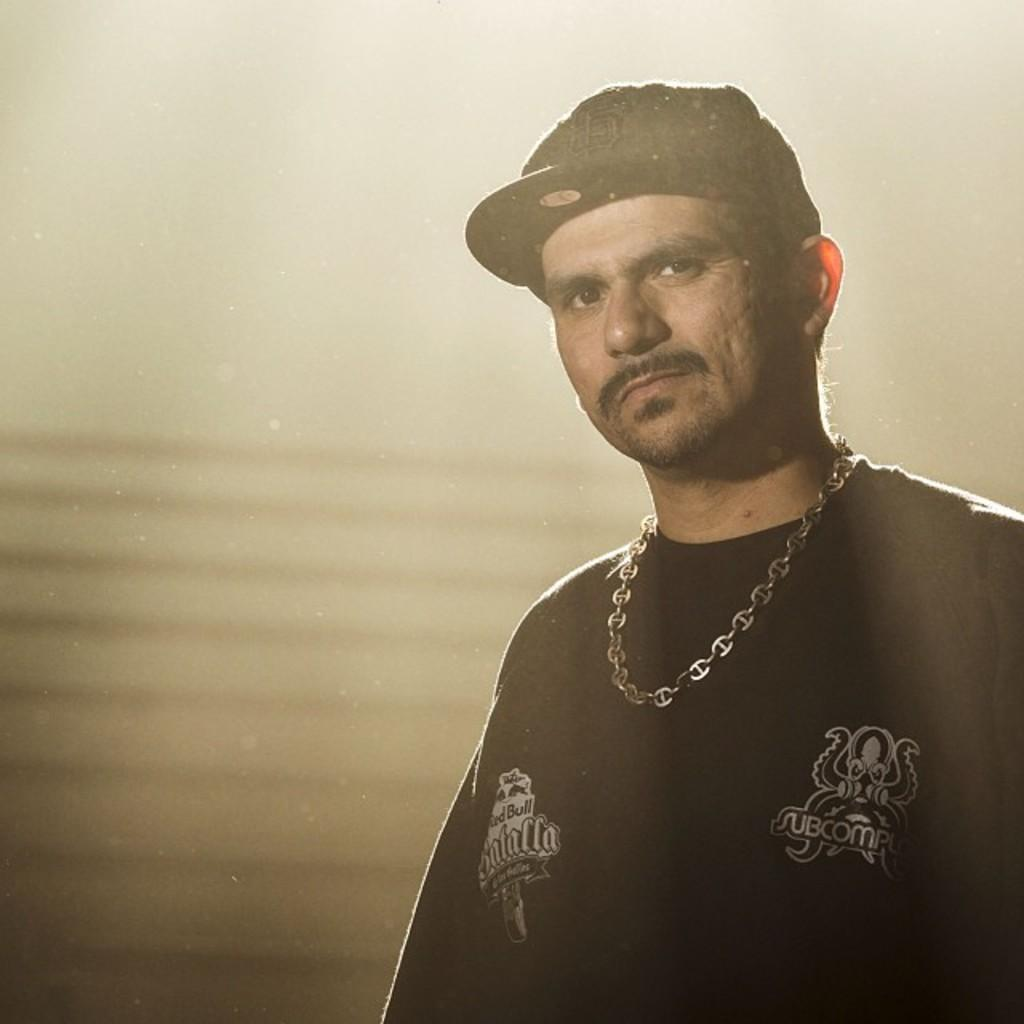Who is in the image? There is a person in the image. What is the person wearing on their upper body? The person is wearing a black t-shirt. What type of accessory is the person wearing? The person is wearing a chain. What type of headwear is the person wearing? The person is wearing a cap. What direction is the person looking in the image? The person is looking forward. How would you describe the background of the image? The background of the image is blurred. What type of birthday celebration is depicted in the image? There is no birthday celebration depicted in the image; it only features a person wearing a black t-shirt, chain, and cap, with a blurred background. 